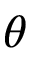Convert formula to latex. <formula><loc_0><loc_0><loc_500><loc_500>\theta</formula> 